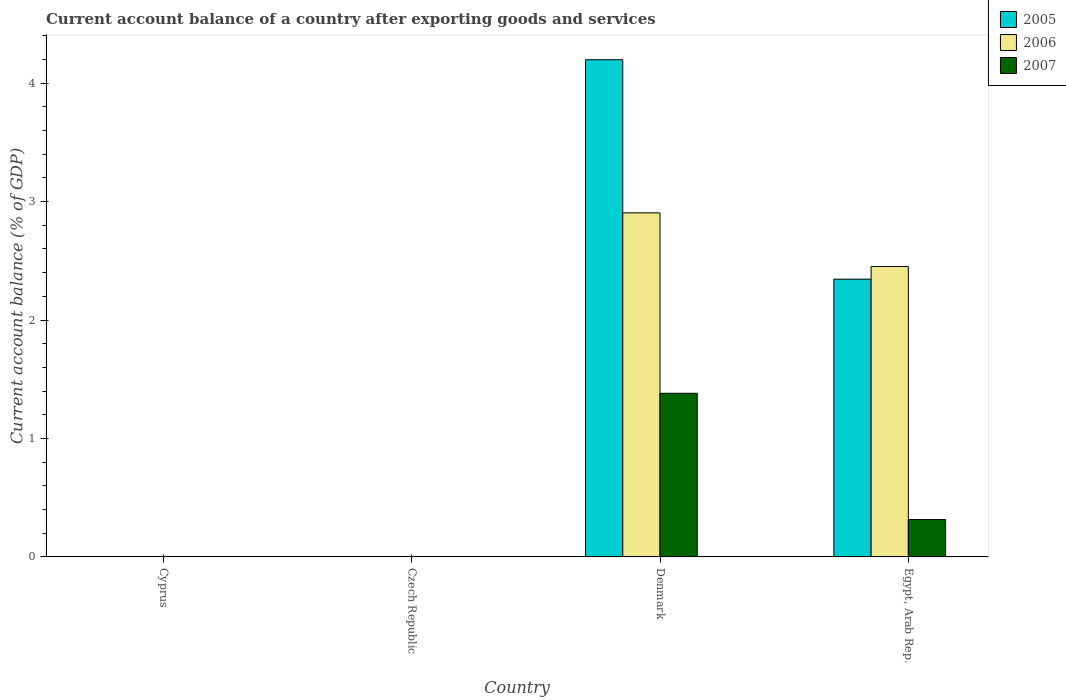How many different coloured bars are there?
Make the answer very short. 3. Are the number of bars per tick equal to the number of legend labels?
Offer a terse response. No. How many bars are there on the 1st tick from the right?
Ensure brevity in your answer.  3. What is the label of the 4th group of bars from the left?
Offer a terse response. Egypt, Arab Rep. Across all countries, what is the maximum account balance in 2005?
Ensure brevity in your answer.  4.2. What is the total account balance in 2005 in the graph?
Offer a very short reply. 6.54. What is the difference between the account balance in 2005 in Denmark and that in Egypt, Arab Rep.?
Provide a succinct answer. 1.85. What is the difference between the account balance in 2005 in Egypt, Arab Rep. and the account balance in 2006 in Denmark?
Your answer should be very brief. -0.56. What is the average account balance in 2005 per country?
Your answer should be compact. 1.64. What is the difference between the account balance of/in 2005 and account balance of/in 2007 in Egypt, Arab Rep.?
Provide a succinct answer. 2.03. What is the ratio of the account balance in 2005 in Denmark to that in Egypt, Arab Rep.?
Provide a succinct answer. 1.79. What is the difference between the highest and the lowest account balance in 2005?
Offer a terse response. 4.2. Is it the case that in every country, the sum of the account balance in 2006 and account balance in 2007 is greater than the account balance in 2005?
Ensure brevity in your answer.  No. Are all the bars in the graph horizontal?
Your answer should be compact. No. How many countries are there in the graph?
Your answer should be compact. 4. What is the difference between two consecutive major ticks on the Y-axis?
Offer a very short reply. 1. Does the graph contain any zero values?
Keep it short and to the point. Yes. Does the graph contain grids?
Keep it short and to the point. No. Where does the legend appear in the graph?
Offer a terse response. Top right. What is the title of the graph?
Provide a short and direct response. Current account balance of a country after exporting goods and services. Does "1980" appear as one of the legend labels in the graph?
Your answer should be compact. No. What is the label or title of the X-axis?
Offer a terse response. Country. What is the label or title of the Y-axis?
Provide a succinct answer. Current account balance (% of GDP). What is the Current account balance (% of GDP) of 2007 in Czech Republic?
Ensure brevity in your answer.  0. What is the Current account balance (% of GDP) in 2005 in Denmark?
Your response must be concise. 4.2. What is the Current account balance (% of GDP) of 2006 in Denmark?
Your response must be concise. 2.9. What is the Current account balance (% of GDP) of 2007 in Denmark?
Offer a terse response. 1.38. What is the Current account balance (% of GDP) in 2005 in Egypt, Arab Rep.?
Make the answer very short. 2.34. What is the Current account balance (% of GDP) of 2006 in Egypt, Arab Rep.?
Ensure brevity in your answer.  2.45. What is the Current account balance (% of GDP) in 2007 in Egypt, Arab Rep.?
Give a very brief answer. 0.32. Across all countries, what is the maximum Current account balance (% of GDP) in 2005?
Offer a terse response. 4.2. Across all countries, what is the maximum Current account balance (% of GDP) in 2006?
Provide a succinct answer. 2.9. Across all countries, what is the maximum Current account balance (% of GDP) in 2007?
Ensure brevity in your answer.  1.38. What is the total Current account balance (% of GDP) of 2005 in the graph?
Ensure brevity in your answer.  6.54. What is the total Current account balance (% of GDP) of 2006 in the graph?
Provide a short and direct response. 5.36. What is the total Current account balance (% of GDP) of 2007 in the graph?
Give a very brief answer. 1.7. What is the difference between the Current account balance (% of GDP) of 2005 in Denmark and that in Egypt, Arab Rep.?
Your answer should be compact. 1.85. What is the difference between the Current account balance (% of GDP) in 2006 in Denmark and that in Egypt, Arab Rep.?
Provide a short and direct response. 0.45. What is the difference between the Current account balance (% of GDP) of 2007 in Denmark and that in Egypt, Arab Rep.?
Ensure brevity in your answer.  1.07. What is the difference between the Current account balance (% of GDP) in 2005 in Denmark and the Current account balance (% of GDP) in 2006 in Egypt, Arab Rep.?
Your response must be concise. 1.75. What is the difference between the Current account balance (% of GDP) of 2005 in Denmark and the Current account balance (% of GDP) of 2007 in Egypt, Arab Rep.?
Offer a very short reply. 3.88. What is the difference between the Current account balance (% of GDP) of 2006 in Denmark and the Current account balance (% of GDP) of 2007 in Egypt, Arab Rep.?
Ensure brevity in your answer.  2.59. What is the average Current account balance (% of GDP) in 2005 per country?
Offer a very short reply. 1.64. What is the average Current account balance (% of GDP) in 2006 per country?
Give a very brief answer. 1.34. What is the average Current account balance (% of GDP) in 2007 per country?
Provide a short and direct response. 0.42. What is the difference between the Current account balance (% of GDP) of 2005 and Current account balance (% of GDP) of 2006 in Denmark?
Your response must be concise. 1.29. What is the difference between the Current account balance (% of GDP) of 2005 and Current account balance (% of GDP) of 2007 in Denmark?
Provide a succinct answer. 2.82. What is the difference between the Current account balance (% of GDP) in 2006 and Current account balance (% of GDP) in 2007 in Denmark?
Make the answer very short. 1.52. What is the difference between the Current account balance (% of GDP) in 2005 and Current account balance (% of GDP) in 2006 in Egypt, Arab Rep.?
Make the answer very short. -0.11. What is the difference between the Current account balance (% of GDP) of 2005 and Current account balance (% of GDP) of 2007 in Egypt, Arab Rep.?
Make the answer very short. 2.03. What is the difference between the Current account balance (% of GDP) of 2006 and Current account balance (% of GDP) of 2007 in Egypt, Arab Rep.?
Keep it short and to the point. 2.14. What is the ratio of the Current account balance (% of GDP) in 2005 in Denmark to that in Egypt, Arab Rep.?
Provide a short and direct response. 1.79. What is the ratio of the Current account balance (% of GDP) in 2006 in Denmark to that in Egypt, Arab Rep.?
Make the answer very short. 1.18. What is the ratio of the Current account balance (% of GDP) in 2007 in Denmark to that in Egypt, Arab Rep.?
Ensure brevity in your answer.  4.38. What is the difference between the highest and the lowest Current account balance (% of GDP) in 2005?
Offer a very short reply. 4.2. What is the difference between the highest and the lowest Current account balance (% of GDP) of 2006?
Provide a short and direct response. 2.9. What is the difference between the highest and the lowest Current account balance (% of GDP) in 2007?
Ensure brevity in your answer.  1.38. 